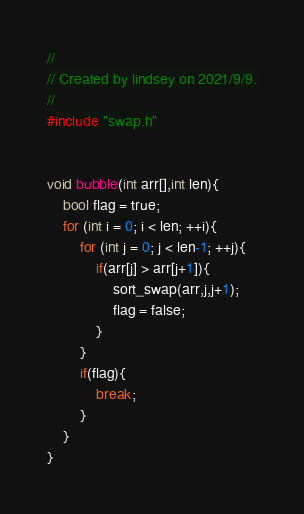Convert code to text. <code><loc_0><loc_0><loc_500><loc_500><_C++_>//
// Created by lindsey on 2021/9/9.
//
#include "swap.h"


void bubble(int arr[],int len){
    bool flag = true;
    for (int i = 0; i < len; ++i){
        for (int j = 0; j < len-1; ++j){
            if(arr[j] > arr[j+1]){
                sort_swap(arr,j,j+1);
                flag = false;
            }
        }
        if(flag){
            break;
        }
    }
}</code> 